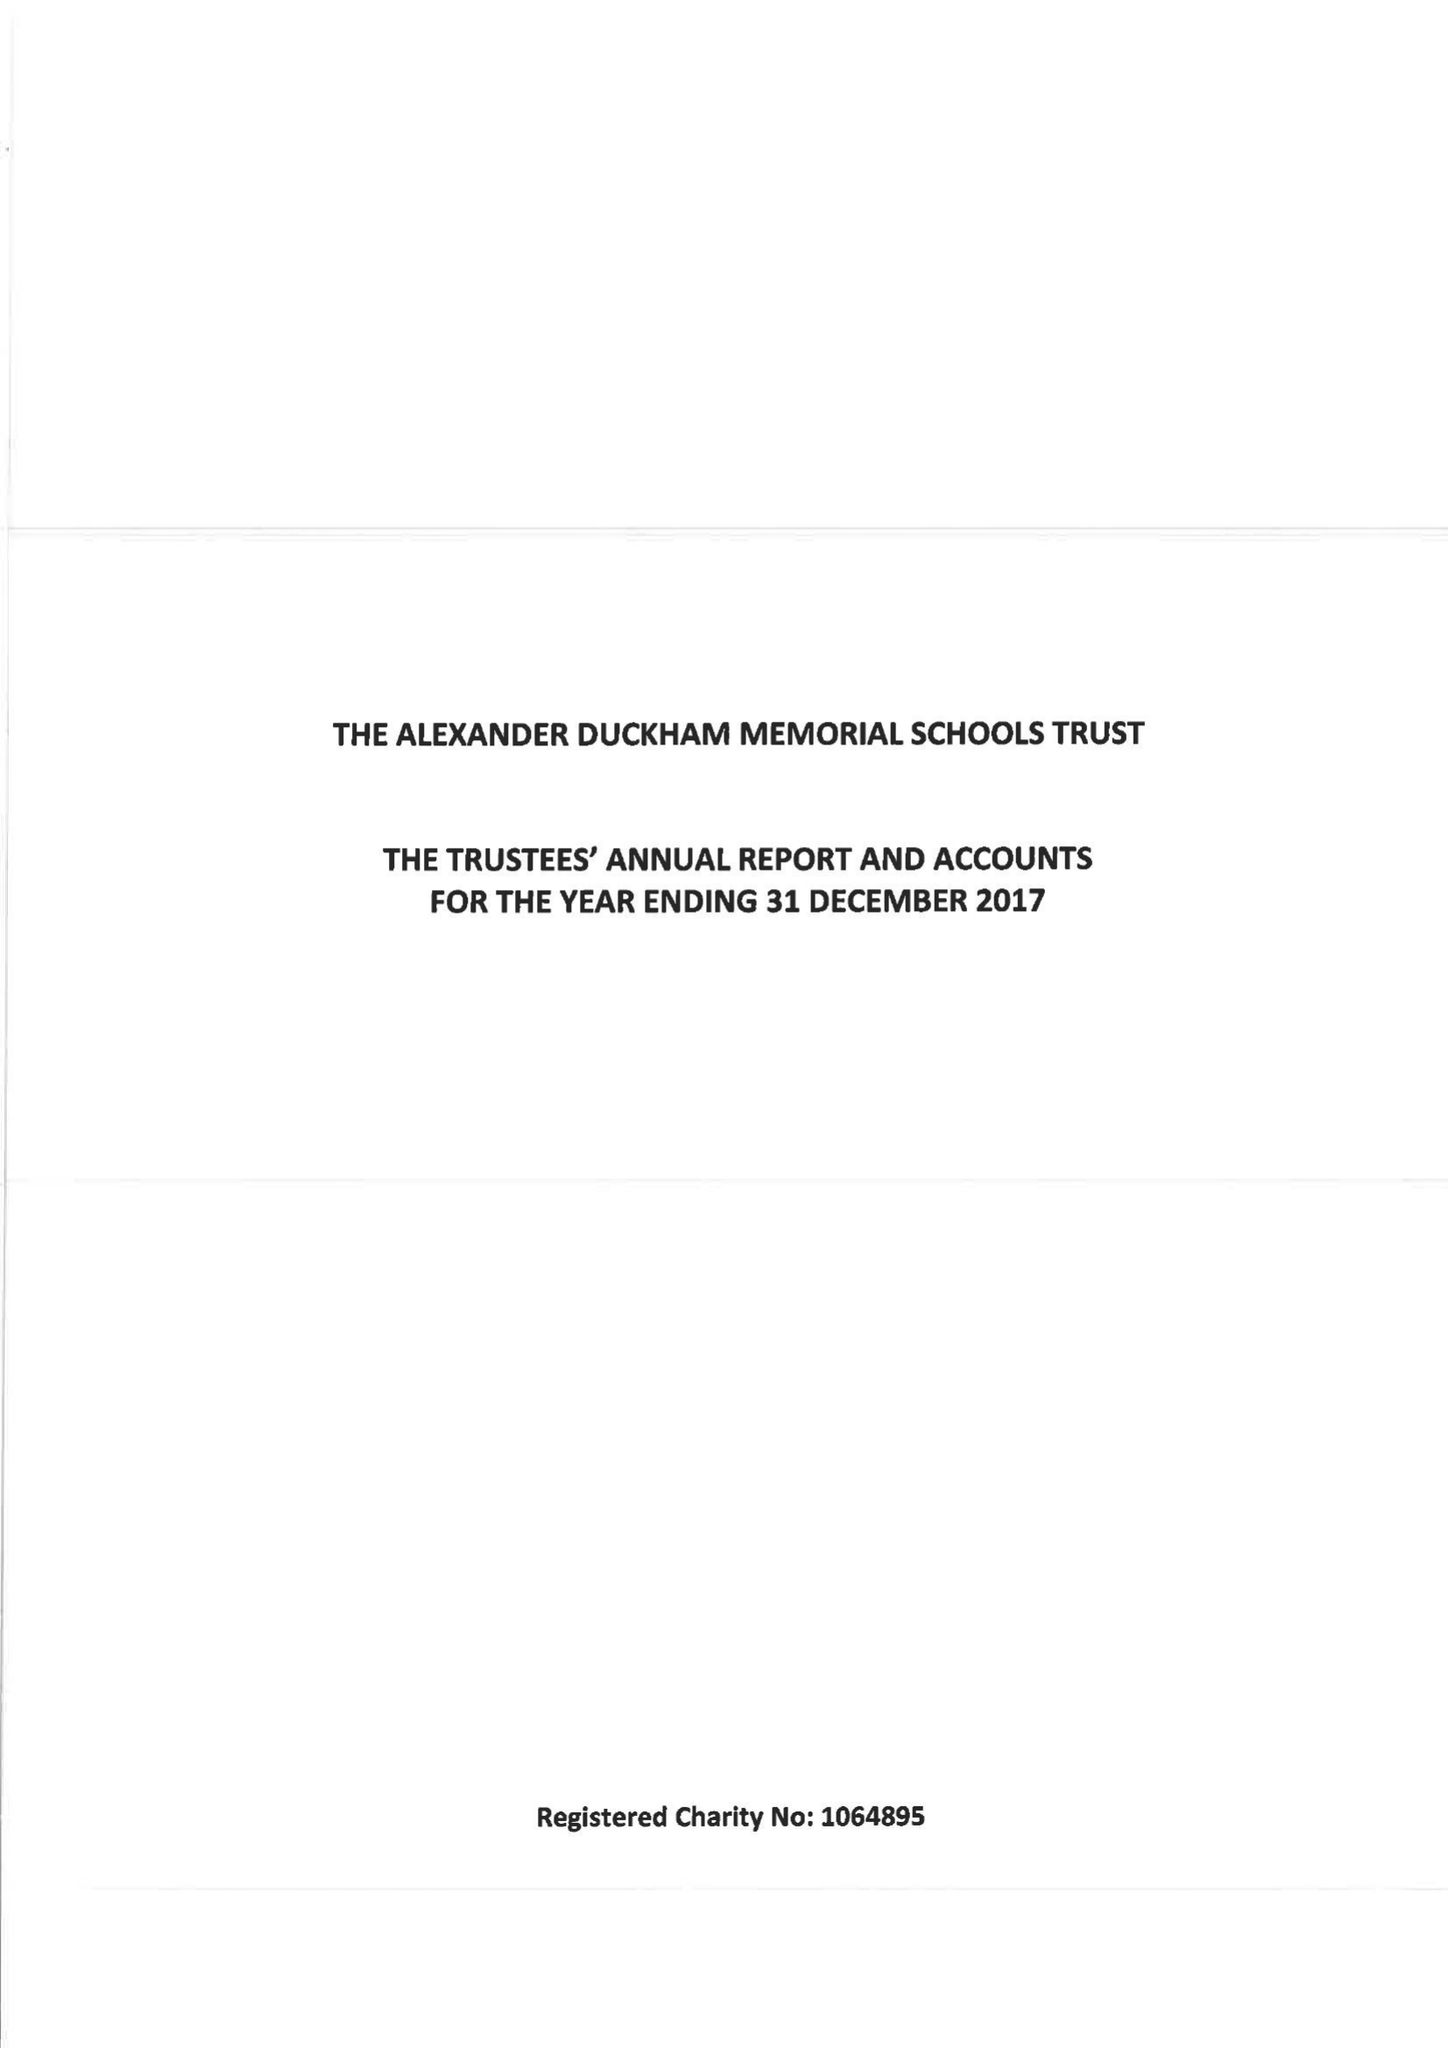What is the value for the address__postcode?
Answer the question using a single word or phrase. SW15 6RU 